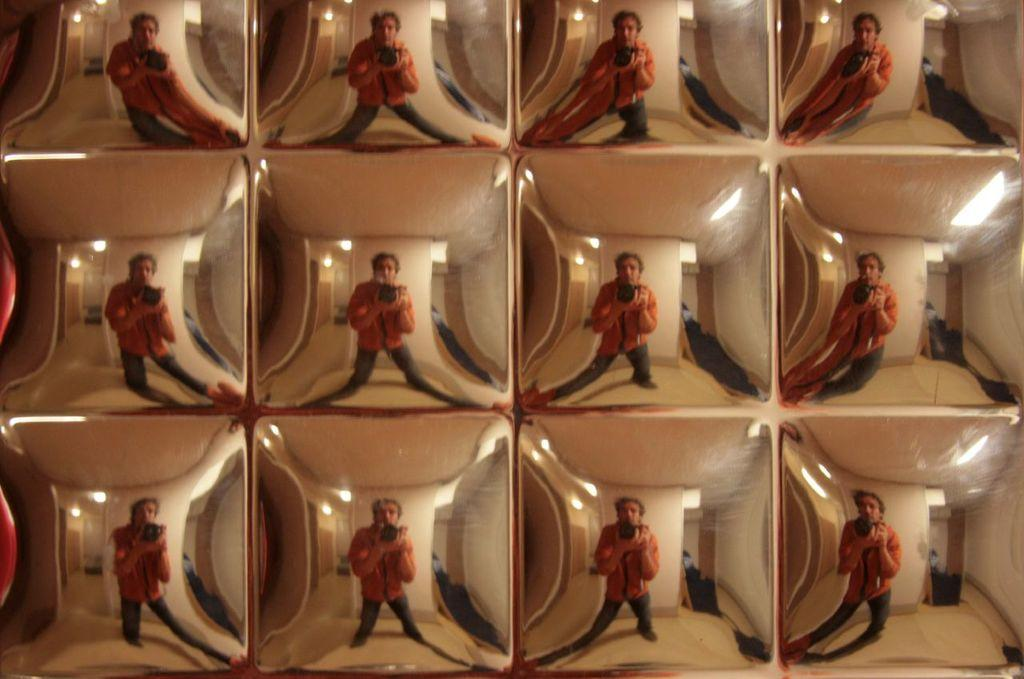What can be seen in the image that suggests someone was present? There is a reflection of a person in the image. What object is likely responsible for capturing the reflection? There is a camera in the image. What type of setting is visible in the image? The interior of a house is visible in the image. Can you tell me how many doors are visible in the image? There is no door visible in the image; the image shows a reflection of a person and a camera in the interior of a house. Is there a giraffe in the image? No, there is no giraffe present in the image. 